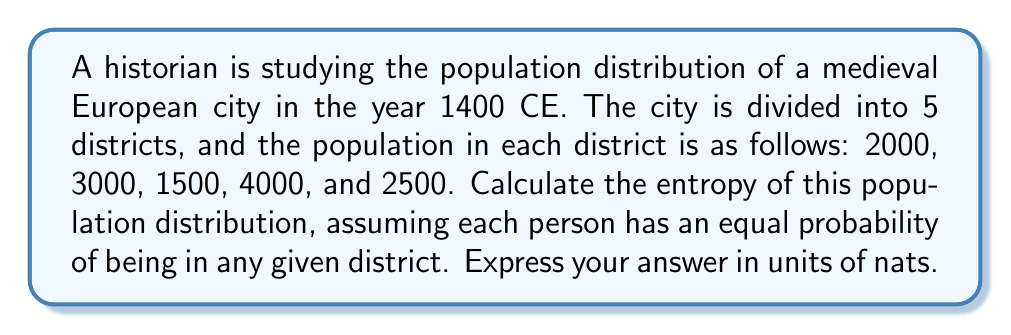Solve this math problem. To calculate the entropy of this population distribution, we'll follow these steps:

1. Calculate the total population:
   $N = 2000 + 3000 + 1500 + 4000 + 2500 = 13000$

2. Calculate the probability of a person being in each district:
   $p_1 = 2000/13000 = 0.1538$
   $p_2 = 3000/13000 = 0.2308$
   $p_3 = 1500/13000 = 0.1154$
   $p_4 = 4000/13000 = 0.3077$
   $p_5 = 2500/13000 = 0.1923$

3. Use the entropy formula:
   $S = -\sum_{i=1}^{5} p_i \ln(p_i)$

4. Calculate each term:
   $-p_1 \ln(p_1) = -0.1538 \ln(0.1538) = 0.2879$
   $-p_2 \ln(p_2) = -0.2308 \ln(0.2308) = 0.3383$
   $-p_3 \ln(p_3) = -0.1154 \ln(0.1154) = 0.2479$
   $-p_4 \ln(p_4) = -0.3077 \ln(0.3077) = 0.3622$
   $-p_5 \ln(p_5) = -0.1923 \ln(0.1923) = 0.3164$

5. Sum all terms:
   $S = 0.2879 + 0.3383 + 0.2479 + 0.3622 + 0.3164 = 1.5527$ nats
Answer: 1.5527 nats 